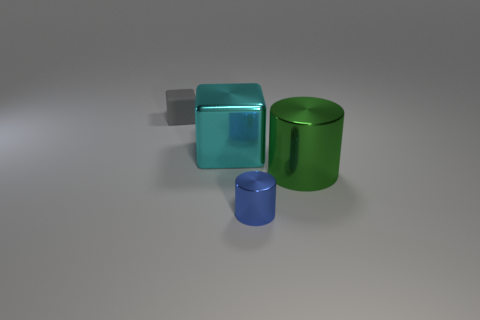Which object in the image has reflective properties? All three objects in the image exhibit reflective properties, as indicated by the visible gleam on their surfaces. 